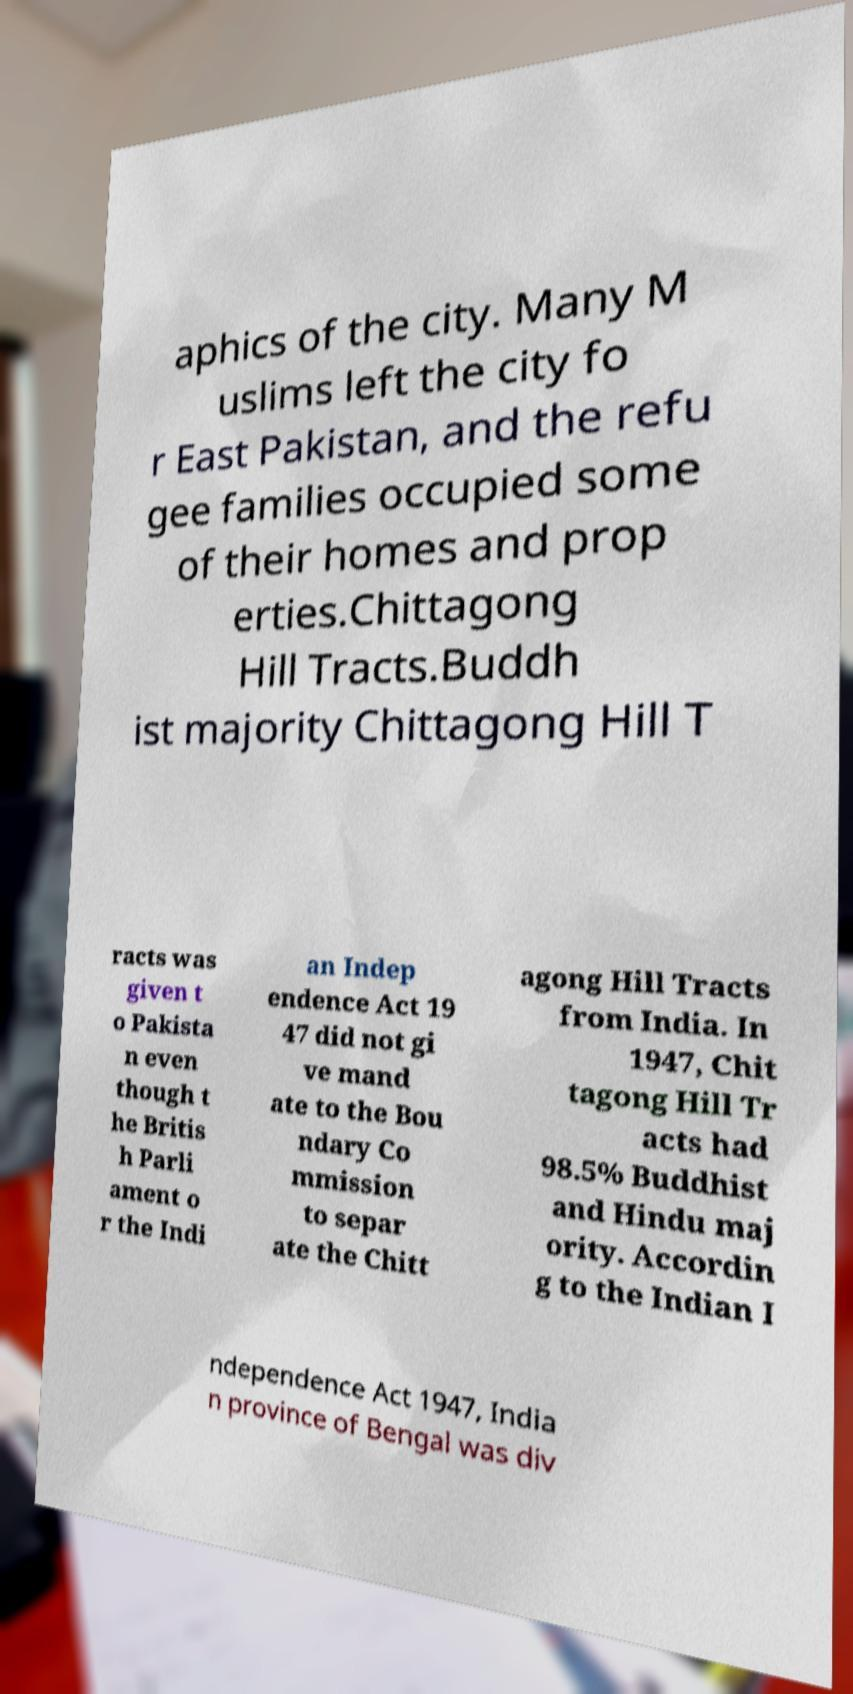Could you assist in decoding the text presented in this image and type it out clearly? aphics of the city. Many M uslims left the city fo r East Pakistan, and the refu gee families occupied some of their homes and prop erties.Chittagong Hill Tracts.Buddh ist majority Chittagong Hill T racts was given t o Pakista n even though t he Britis h Parli ament o r the Indi an Indep endence Act 19 47 did not gi ve mand ate to the Bou ndary Co mmission to separ ate the Chitt agong Hill Tracts from India. In 1947, Chit tagong Hill Tr acts had 98.5% Buddhist and Hindu maj ority. Accordin g to the Indian I ndependence Act 1947, India n province of Bengal was div 